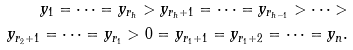<formula> <loc_0><loc_0><loc_500><loc_500>y _ { 1 } = \cdots = y _ { r _ { h } } > y _ { r _ { h } + 1 } = \cdots = y _ { r _ { h - 1 } } > \cdots > \\ y _ { r _ { 2 } + 1 } = \cdots = y _ { r _ { 1 } } > 0 = y _ { r _ { 1 } + 1 } = y _ { r _ { 1 } + 2 } = \cdots = y _ { n } .</formula> 